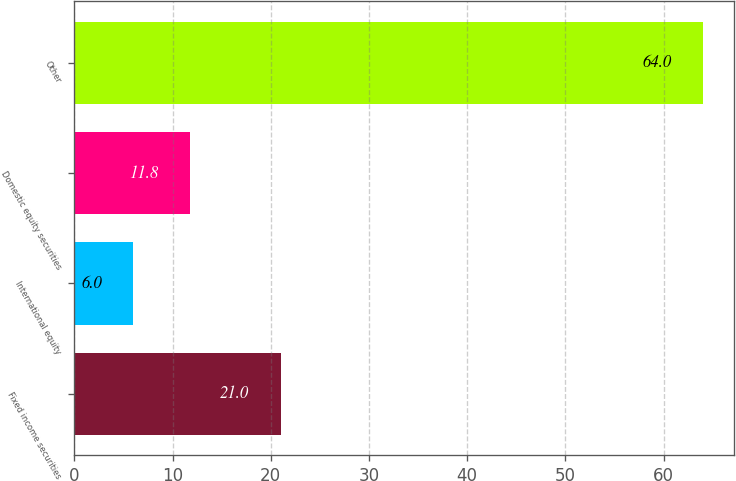Convert chart to OTSL. <chart><loc_0><loc_0><loc_500><loc_500><bar_chart><fcel>Fixed income securities<fcel>International equity<fcel>Domestic equity securities<fcel>Other<nl><fcel>21<fcel>6<fcel>11.8<fcel>64<nl></chart> 